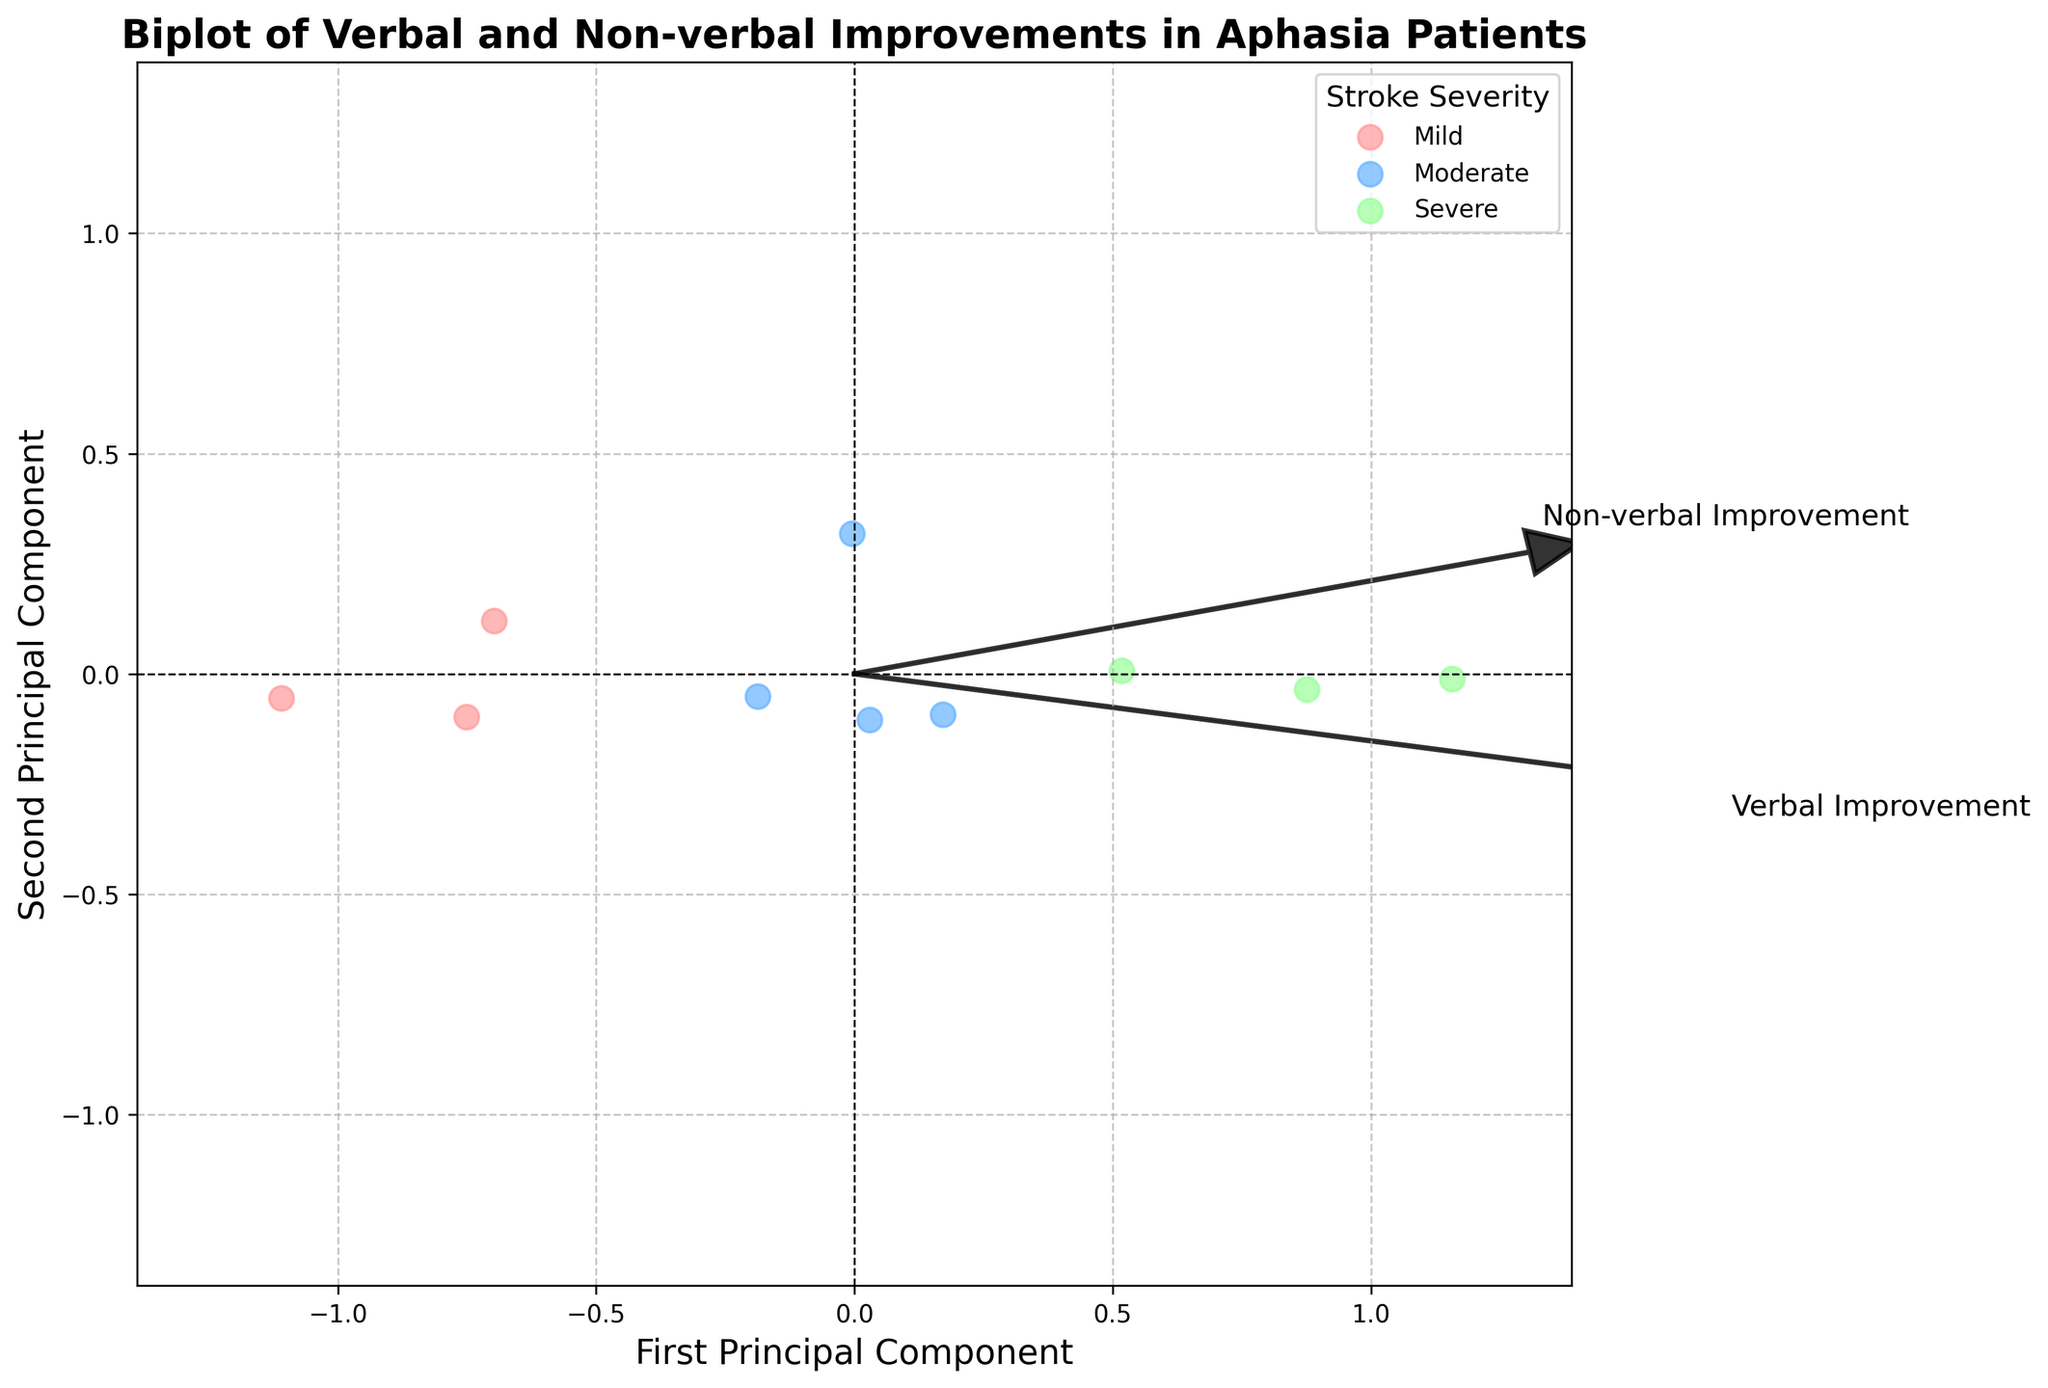What is the title of the biplot? The title is prominently shown at the top of the figure.
Answer: Biplot of Verbal and Non-verbal Improvements in Aphasia Patients What are the items plotted on the x and y-axes? The x-axis is labeled 'First Principal Component' and the y-axis is labeled 'Second Principal Component'.
Answer: First Principal Component and Second Principal Component How are the data points color-coded? The colors correspond to the severity of the stroke: Mild (light red), Moderate (light blue), and Severe (light green).
Answer: Based on stroke severity Which stroke severity group has the most spread out data points? By visually inspecting the dispersion of the data points, we can see that the 'Severe' group (light green) has data points that appear more spread out.
Answer: Severe Which feature vector is longer? The length of the feature vector indicates its contribution to the principal components. From the arrows, it's clear that 'Non-verbal Improvement' is longer.
Answer: Non-verbal Improvement Are there more data points above or below the origin? Counting the data points above (positive y-values) and below (negative y-values) the horizontal axis, it's evident that there are more data points above the origin.
Answer: Above Which stroke severity has the most data points closely clustered together? The 'Mild' group (shown in light red) has its data points more closely clustered around a central region.
Answer: Mild What is the relative position of 'Non-verbal Improvement' compared to 'Verbal Improvement' in the biplot? 'Non-verbal Improvement' vector points more upward and to the right, while 'Verbal Improvement' points slightly to the right and less upward.
Answer: Higher and more to the right How can you differentiate between 'Moderate' and 'Severe' stroke severity groups based on the plot? By checking the dataset and their corresponding clusters, 'Moderate' (light blue) and 'Severe' (light green) can be differentiated mainly by their position with 'Severe' data points being generally more spread out.
Answer: By color and spread Which principal component seems to explain more variance in the data? The lengths of the arrows along the x and y-axes reflect the data’s variance. The x-axis (First Principal Component) has longer arrows from the origin, indicating it explains more variance.
Answer: First Principal Component 